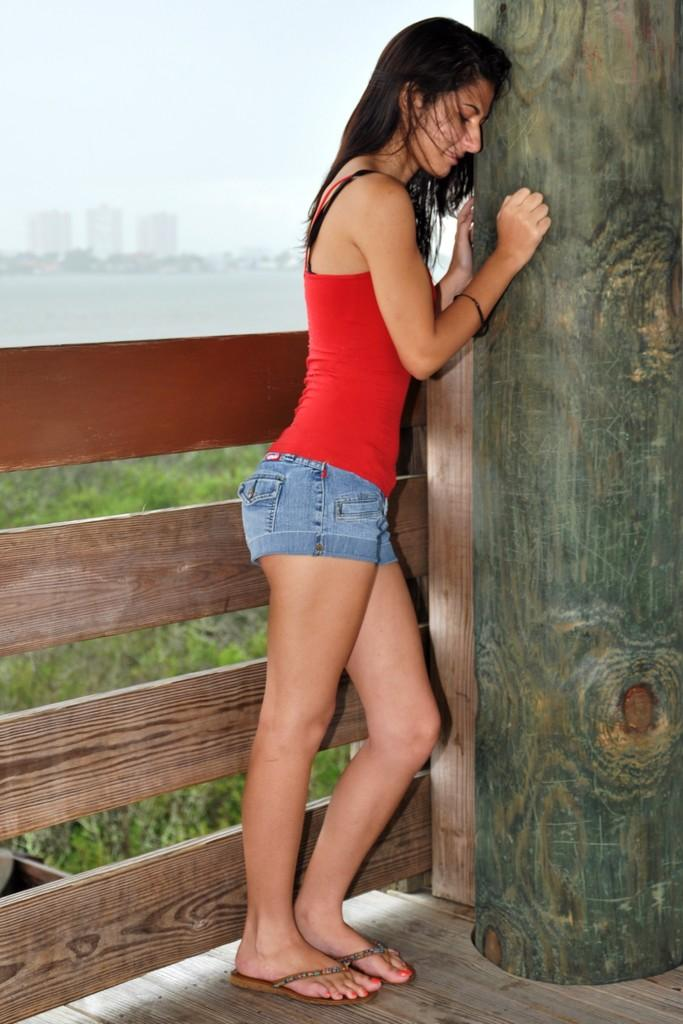What is the woman standing near in the image? The woman is standing near a pillar in the image. What type of fence can be seen in the image? There is a wooden fence in the image. What is visible on the ground in the image? The floor is visible in the image. What type of vegetation is visible in the background? There is grass visible in the background. What natural element can be seen in the background? There is water visible in the background. What type of structures are visible in the background? There are buildings in the background. What part of the natural environment is visible in the background? The sky is visible in the background. What type of steel is used to construct the kettle in the image? There is no kettle present in the image, so it is not possible to determine the type of steel used in its construction. 